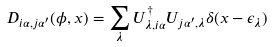<formula> <loc_0><loc_0><loc_500><loc_500>D _ { i \alpha , j \alpha ^ { \prime } } ( \phi , x ) = \sum _ { \lambda } U ^ { \dagger } _ { \lambda , i \alpha } U _ { j \alpha ^ { \prime } , \lambda } \delta ( x - \epsilon _ { \lambda } )</formula> 